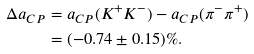<formula> <loc_0><loc_0><loc_500><loc_500>\Delta a _ { C P } & = a _ { C P } ( K ^ { + } K ^ { - } ) - a _ { C P } ( \pi ^ { - } \pi ^ { + } ) \\ & = ( - 0 . 7 4 \pm 0 . 1 5 ) \% .</formula> 